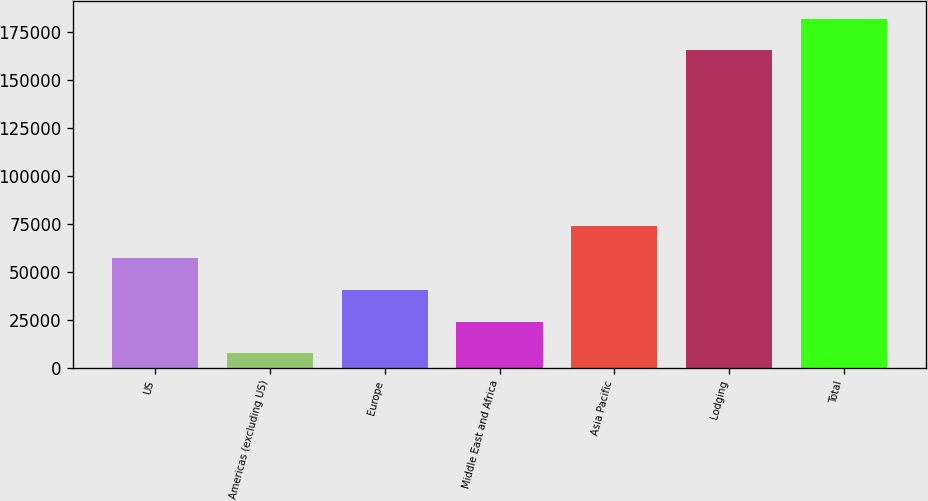<chart> <loc_0><loc_0><loc_500><loc_500><bar_chart><fcel>US<fcel>Americas (excluding US)<fcel>Europe<fcel>Middle East and Africa<fcel>Asia Pacific<fcel>Lodging<fcel>Total<nl><fcel>57095.5<fcel>7432<fcel>40541<fcel>23986.5<fcel>73650<fcel>165320<fcel>181874<nl></chart> 